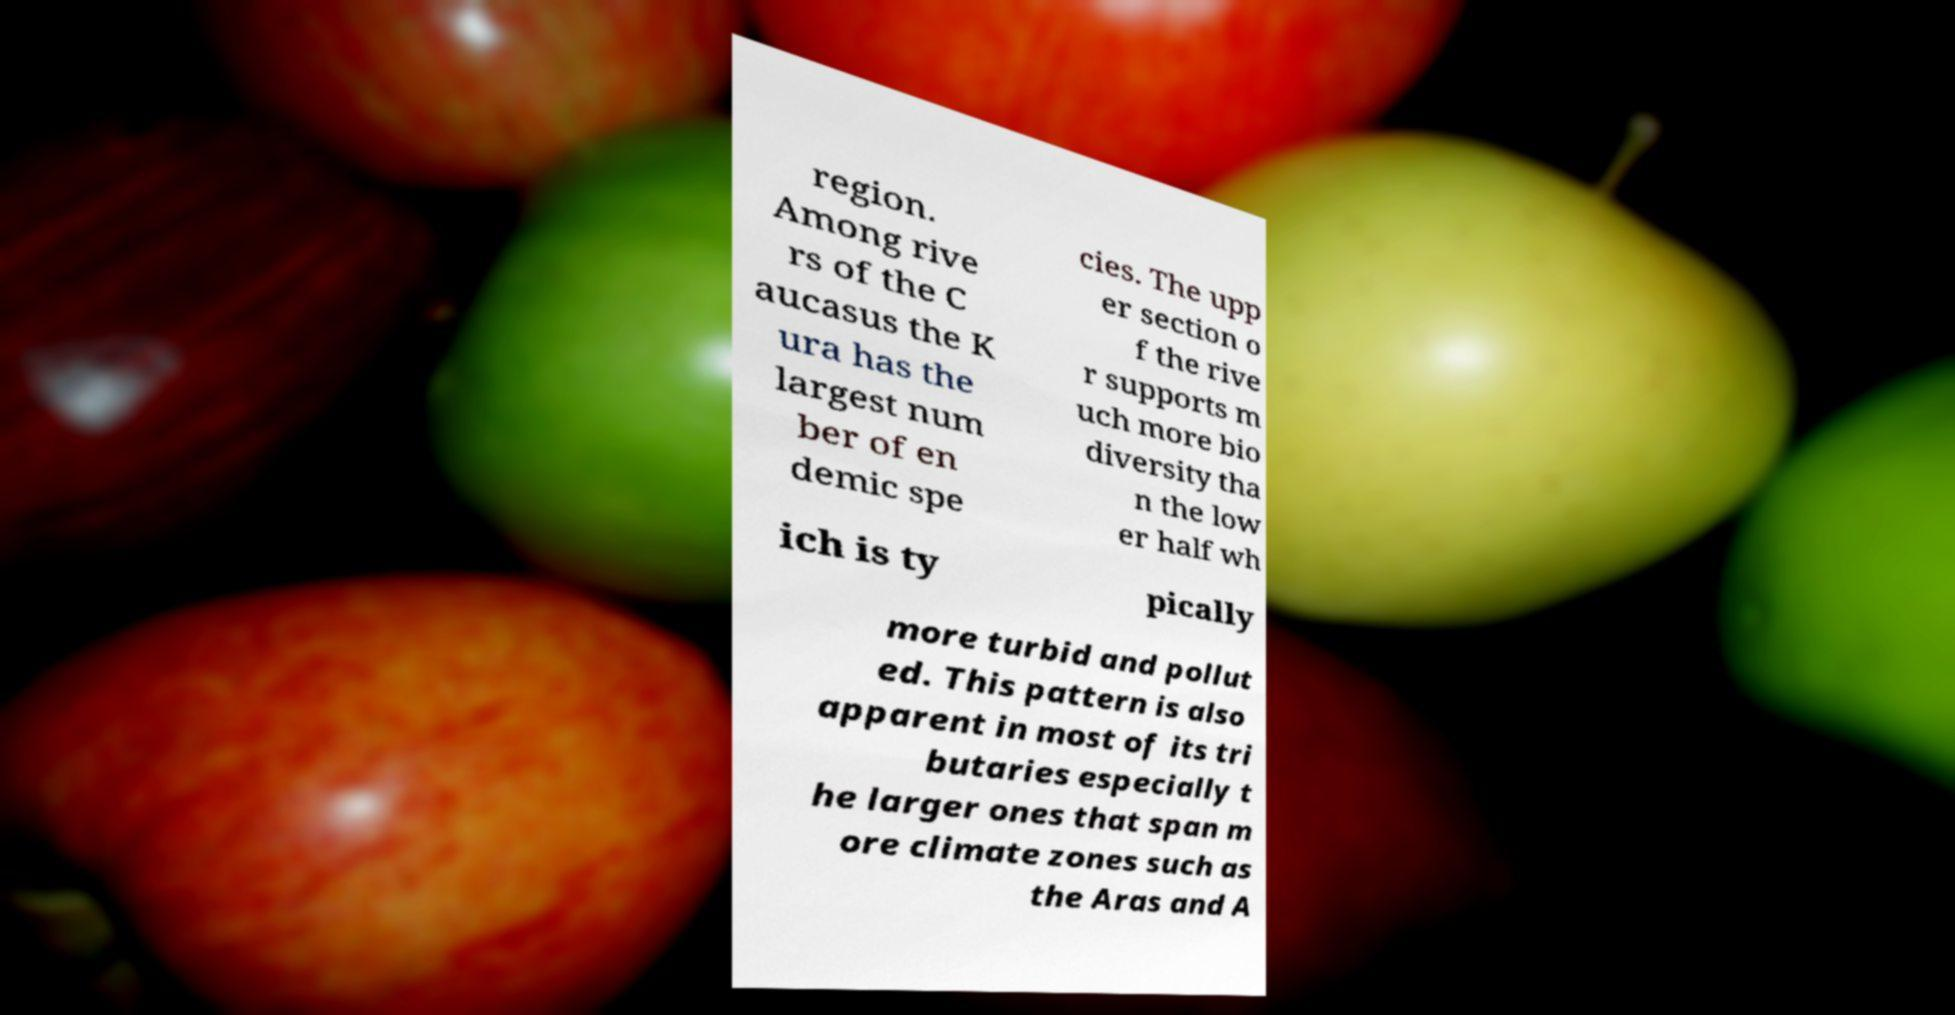Could you assist in decoding the text presented in this image and type it out clearly? region. Among rive rs of the C aucasus the K ura has the largest num ber of en demic spe cies. The upp er section o f the rive r supports m uch more bio diversity tha n the low er half wh ich is ty pically more turbid and pollut ed. This pattern is also apparent in most of its tri butaries especially t he larger ones that span m ore climate zones such as the Aras and A 